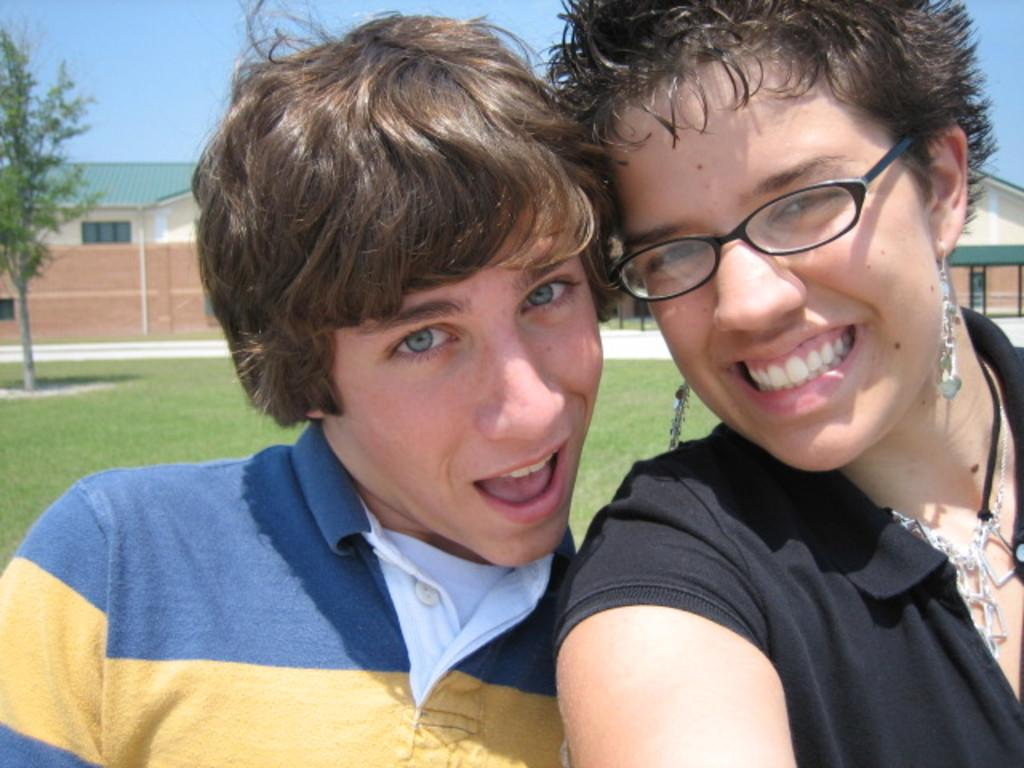How many people are present in the image? There are men and a woman in the image, making a total of three people. What is the color of the landscape in the background? The landscape in the background is green. What other elements can be seen in the background? There is a tree and houses in the background. What is the value of the trees in the image? There is only one tree mentioned in the facts, and it does not have a value associated with it. The image does not provide any information about the value of the tree. 